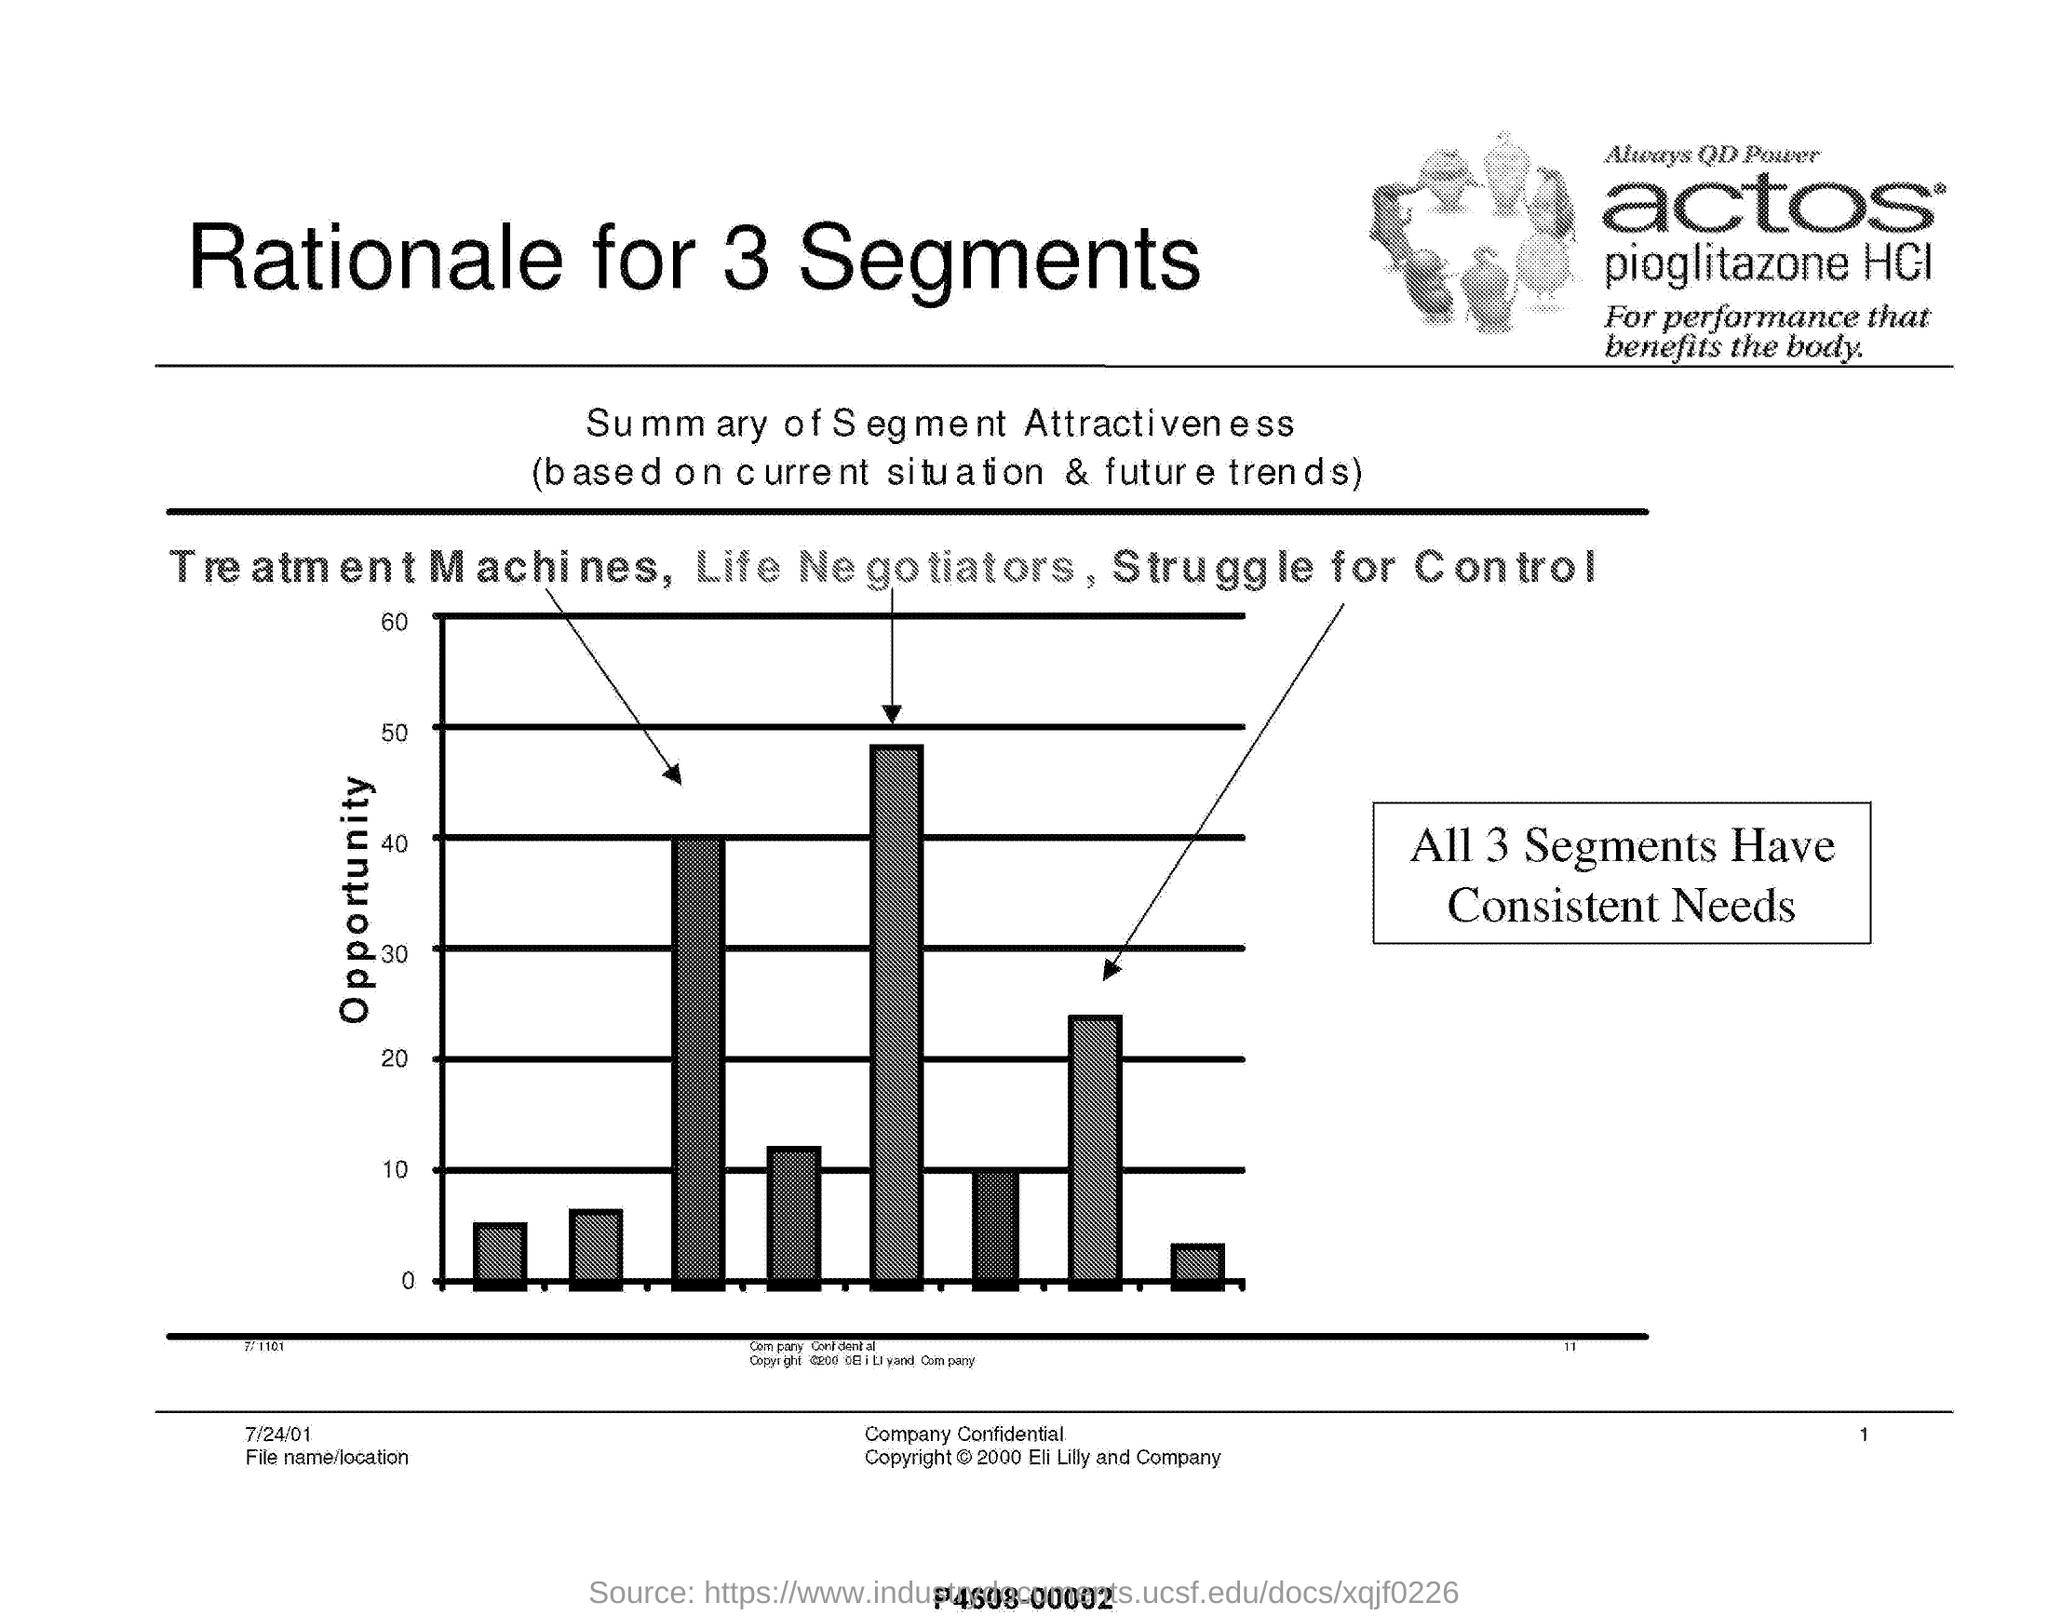What is the heading of this document?
Your response must be concise. Rationale for 3 Segments. What is the graphical representation about?
Keep it short and to the point. Summary of Segment Attractiveness. On what basis, the Summary of Segment Attractiveness is carried out?
Offer a terse response. Current situation & future trends. What are the three segments indicated in the graph?
Make the answer very short. Treatment Machines, Life Negotiators, Struggle for Control. What is the conclusion obtained from the graph?
Ensure brevity in your answer.  All 3 Segments Have Consistent Needs. 